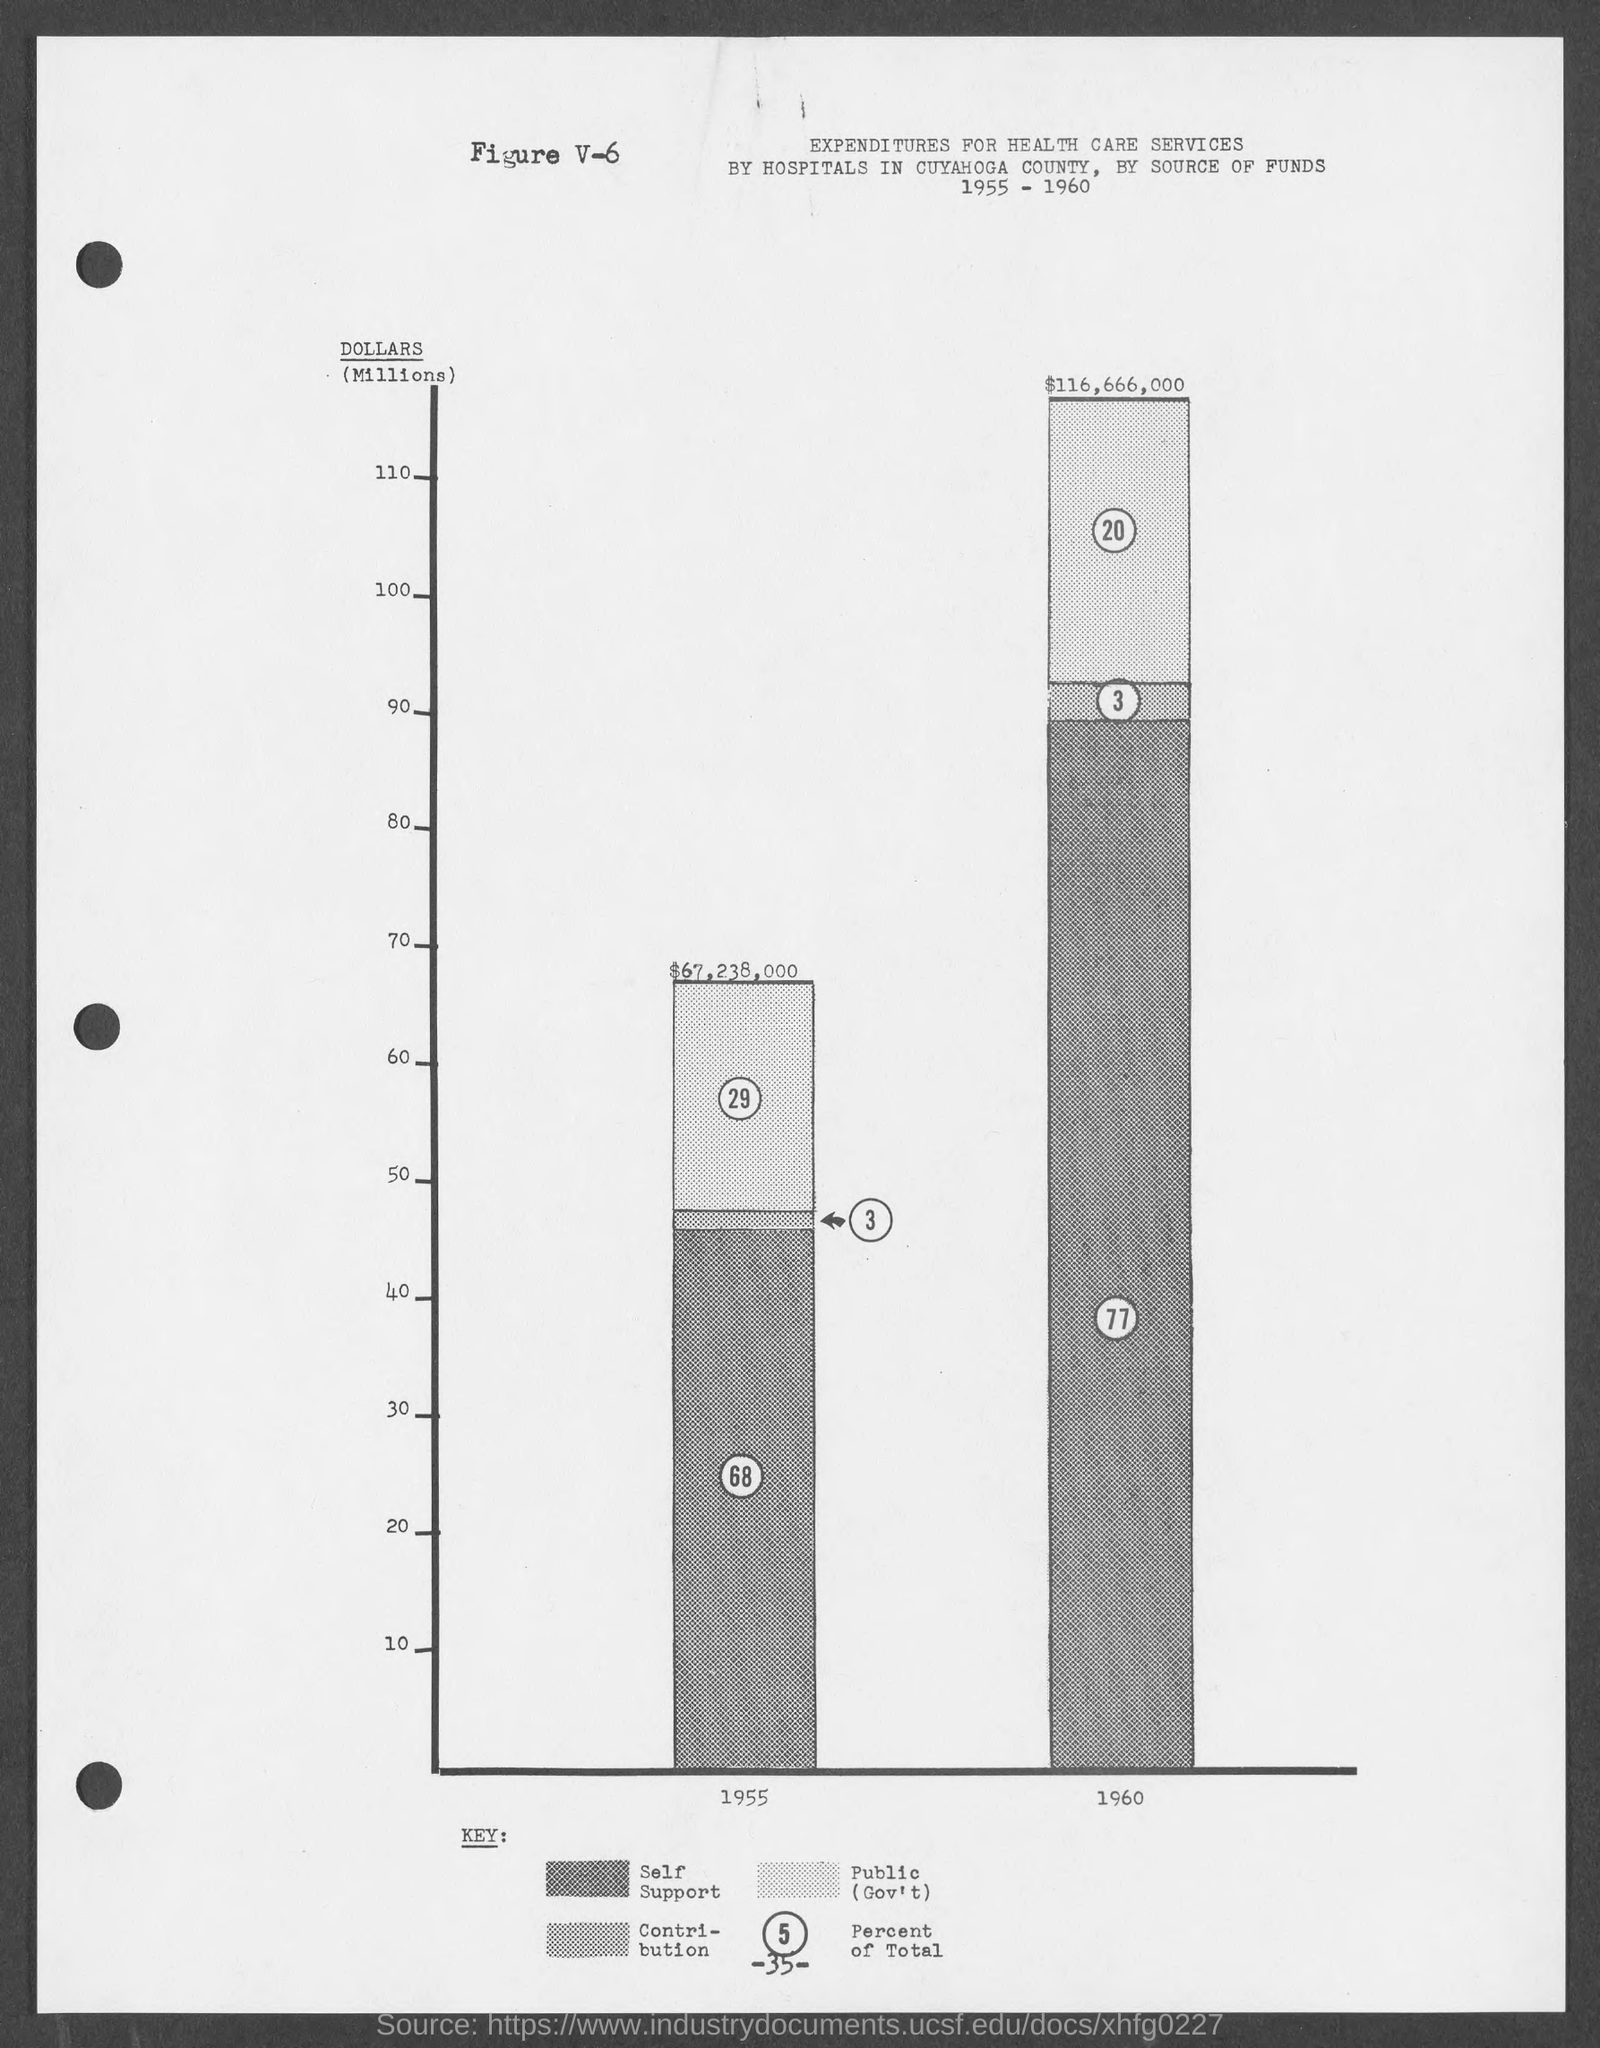What the number at bottom of the page ?
Offer a very short reply. 35. What is the figure no.?
Your answer should be very brief. V-6. 